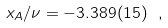<formula> <loc_0><loc_0><loc_500><loc_500>x _ { A } / \nu = - 3 . 3 8 9 ( 1 5 ) \ ,</formula> 